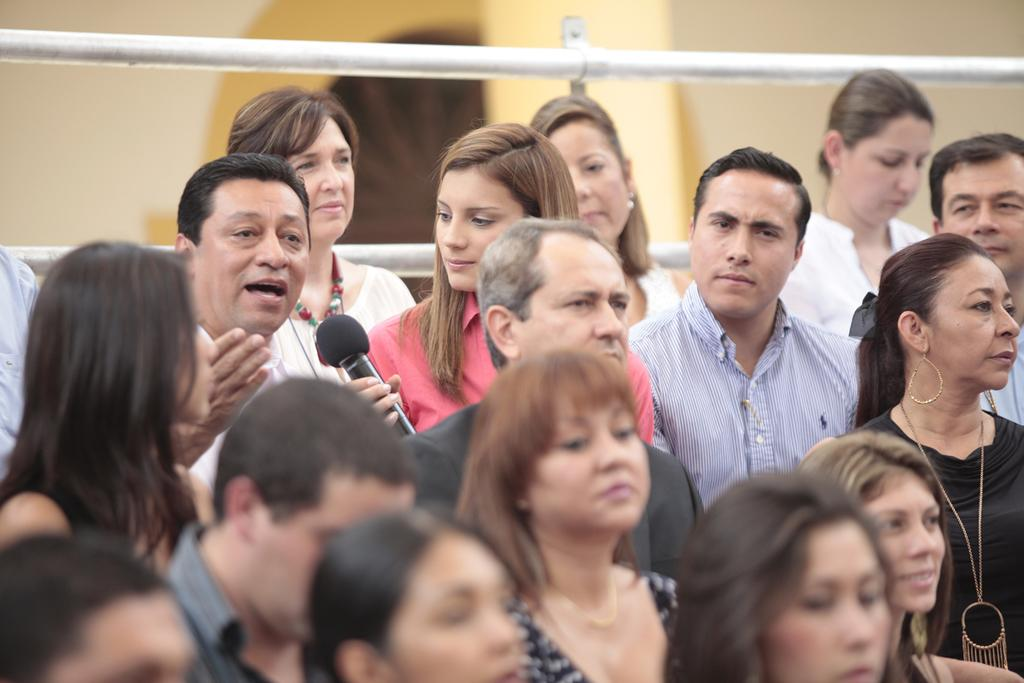What is the general activity of the people in the image? There are groups of people standing in the image. Can you identify any specific object being held by one of the people? Yes, a person is holding a microphone in the image. What can be seen behind the people? There are rods visible behind the people, and there is also a wall behind them. What type of fire can be seen burning behind the people in the image? There is no fire visible behind the people in the image. What industry is represented by the rods behind the people? The image does not provide enough information to determine the specific industry represented by the rods. 